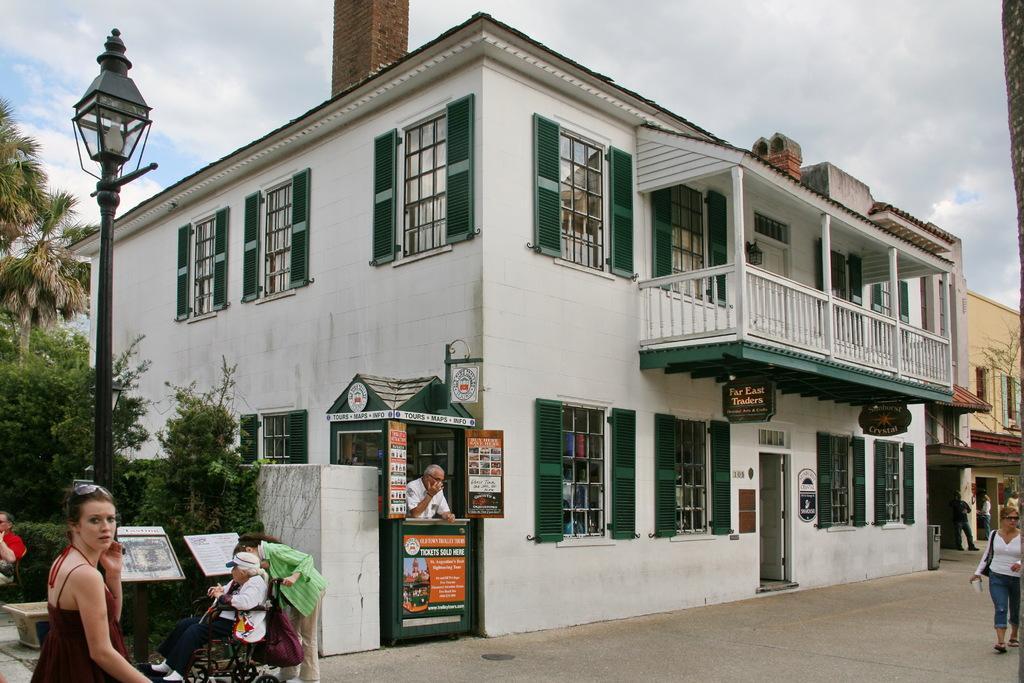Can you describe this image briefly? In this image I can see few people with different color dresses. I can see one person sitting on the wheelchair. To the left I can see light pole and the boards. In the background can see the trees and there are windows to the building. I can also see the sky in the back. 